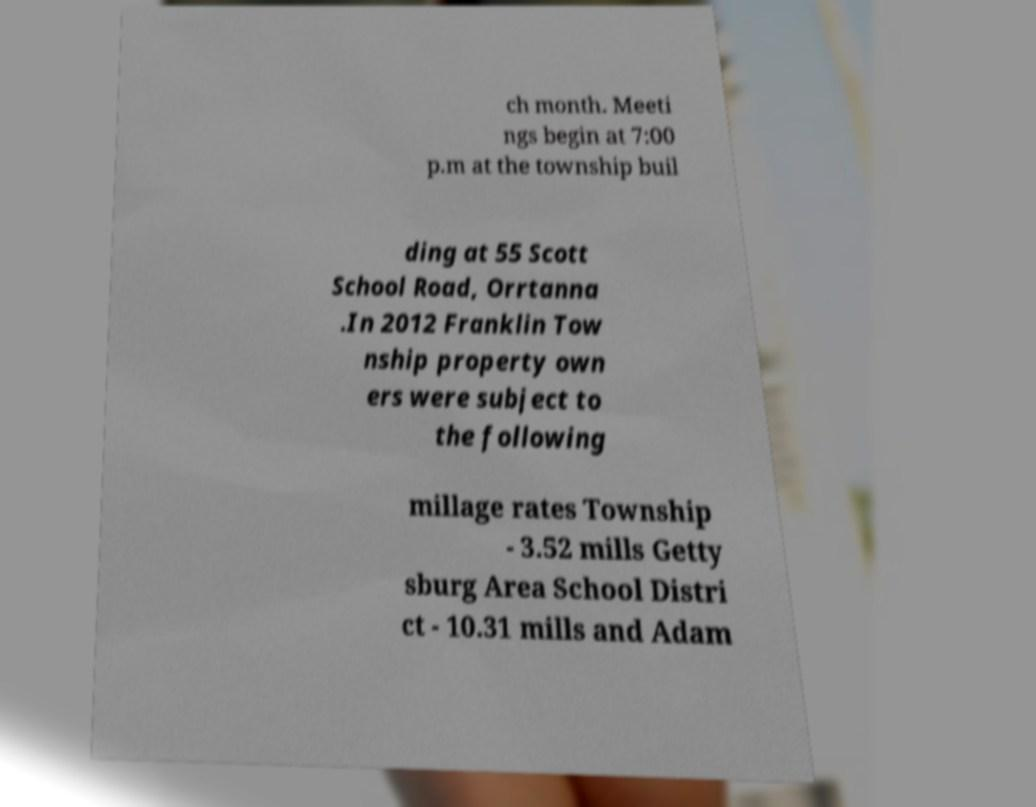Can you read and provide the text displayed in the image?This photo seems to have some interesting text. Can you extract and type it out for me? ch month. Meeti ngs begin at 7:00 p.m at the township buil ding at 55 Scott School Road, Orrtanna .In 2012 Franklin Tow nship property own ers were subject to the following millage rates Township - 3.52 mills Getty sburg Area School Distri ct - 10.31 mills and Adam 